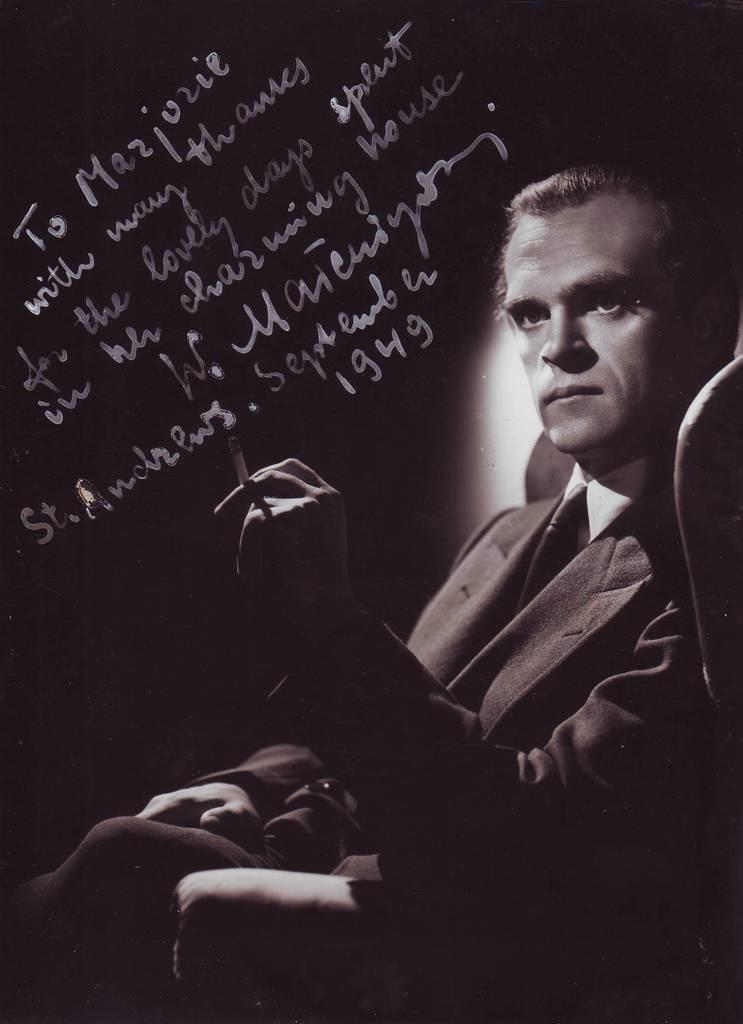What is the man in the image doing? The man is sitting in the image. What is the man holding in his hand? The man is holding a cigarette in his hand. What is the color scheme of the image? The image is black and white in color. Is there any text or writing visible in the image? Yes, there is something written on the image. What type of rhythm does the man's dad play in the image? There is no mention of rhythm, music, or the man's dad in the image. 